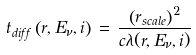<formula> <loc_0><loc_0><loc_500><loc_500>t _ { d i f f } \left ( r , E _ { \nu } , i \right ) \, = \, \frac { \left ( r _ { s c a l e } \right ) ^ { 2 } } { c \lambda ( r , E _ { \nu } , i ) }</formula> 